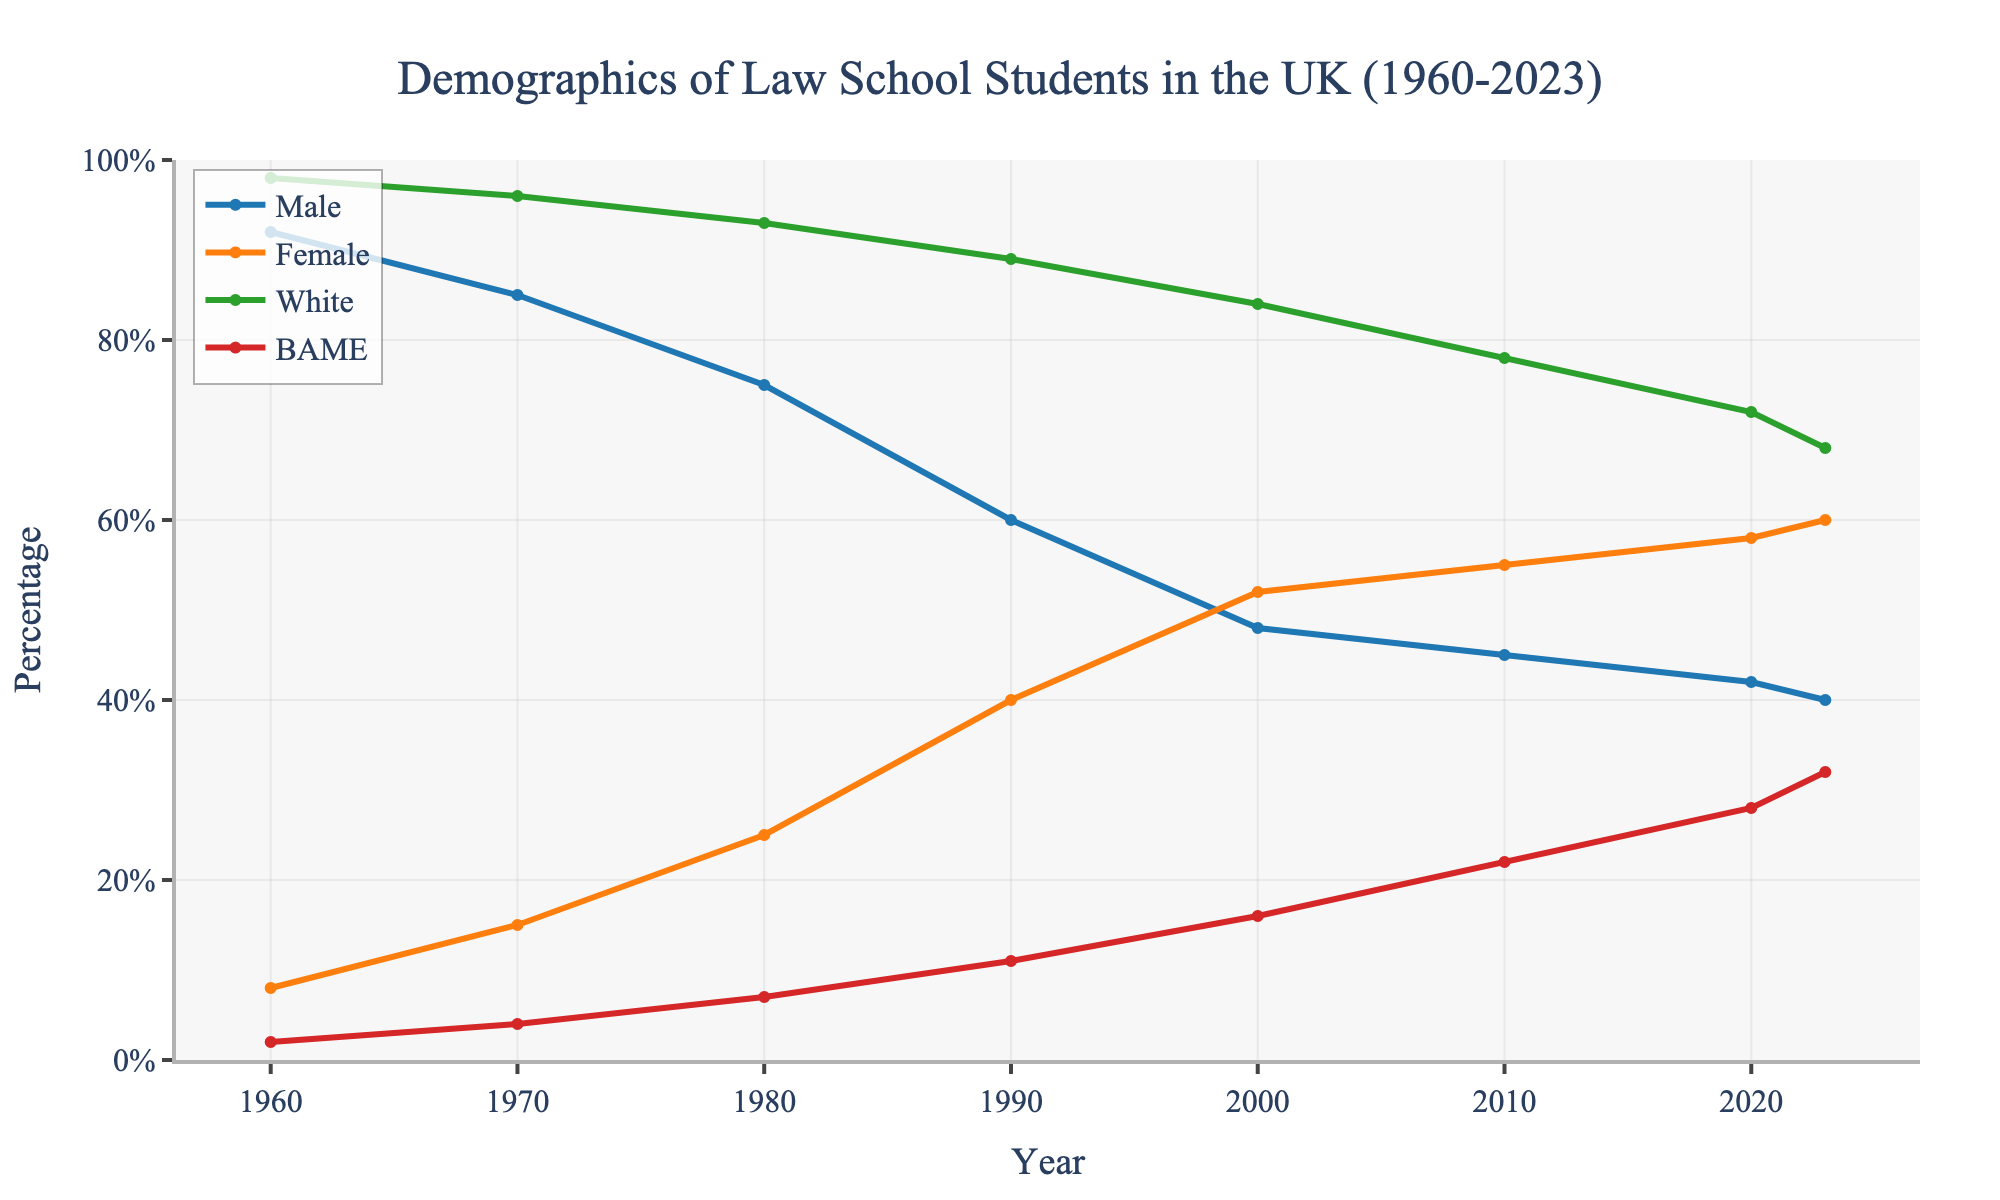How has the percentage of female law school students changed from 1960 to 2023? To find this, look at the value for female law school students in 1960 and in 2023. In 1960, the percentage was 8%, and in 2023, it was 60%. The change can be calculated as 60% - 8% = 52%.
Answer: 52% Which year marks the first time the percentage of female law school students surpasses male law school students? The percentage of female law school students surpasses male students when the female percentage becomes greater than the male percentage. This occurs between 1990 (40% female, 60% male) and 2000 (52% female, 48% male). Therefore, the first year it surpasses is 2000.
Answer: 2000 By how much has the percentage of BAME law school students increased from 1960 to 2023? Look at the percentage of BAME law school students in 1960 and in 2023. In 1960, it was 2%, and in 2023 it was 32%. The increase can be calculated as 32% - 2% = 30%.
Answer: 30% In 2023, which demographic group has the lowest percentage? By observing the values for 2023, the demographic groups are Male (40%), Female (60%), White (68%), and BAME (32%). The lowest percentage is for Male students, which is 40%.
Answer: Male Compare the percentage changes in male law school students between 1960 and 2023. What is the absolute difference? Find the difference in percentages for male law school students between 1960 and 2023. In 1960, the percentage was 92%, and in 2023 it was 40%. The absolute difference is 92% - 40% = 52%.
Answer: 52% During which decade did the percentage of White law school students see the largest decrease? Compare the percentage values for White law school students across each decade and determine the largest decrease. The decades are: 1960-1970, 1970-1980, 1980-1990, 1990-2000, 2000-2010, 2010-2020, 2020-2023. The largest decrease occurred between 2000 (84%) and 2010 (78%), which is a decrease of 6%.
Answer: 2000-2010 What is the total percentage of female and BAME students in 2000? To find the total percentage, add the percentage of female students and BAME students in 2000. In 2000, Female is 52% and BAME is 16%. Thus, the total is 52% + 16% = 68%.
Answer: 68% Which group shows a consistently increasing trend from 1960 to 2023? By examining the trends in the graph, the BAME group shows a consistent increase from 2% in 1960 to 32% in 2023.
Answer: BAME What is the approximate difference in the percentage of White law school students between 2010 and 2023? Look at the values for White law school students in 2010 and 2023. In 2010, it was 78%, and in 2023 it was 68%. The difference is 78% - 68% = 10%.
Answer: 10% During which decade did female students surpass the percentage of White law school students? By comparing the values across each decade, female students surpassed White law school students between 2010 (Female 55%, White 78%) and 2020 (Female 58%, White 72%). Thus, it first happened in the 2010s.
Answer: 2010s 